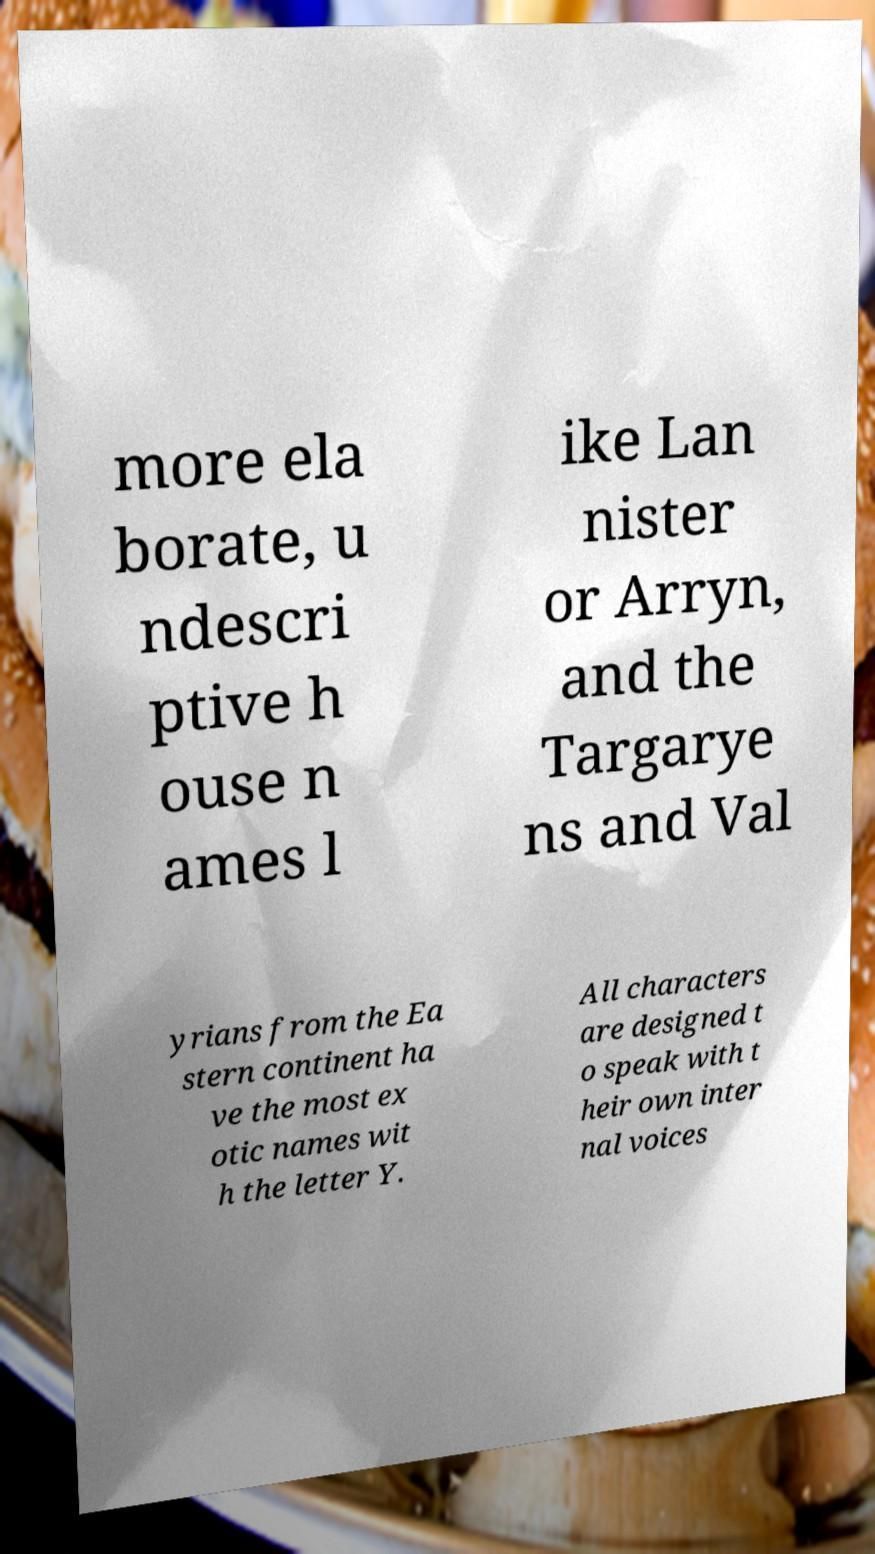Can you read and provide the text displayed in the image?This photo seems to have some interesting text. Can you extract and type it out for me? more ela borate, u ndescri ptive h ouse n ames l ike Lan nister or Arryn, and the Targarye ns and Val yrians from the Ea stern continent ha ve the most ex otic names wit h the letter Y. All characters are designed t o speak with t heir own inter nal voices 